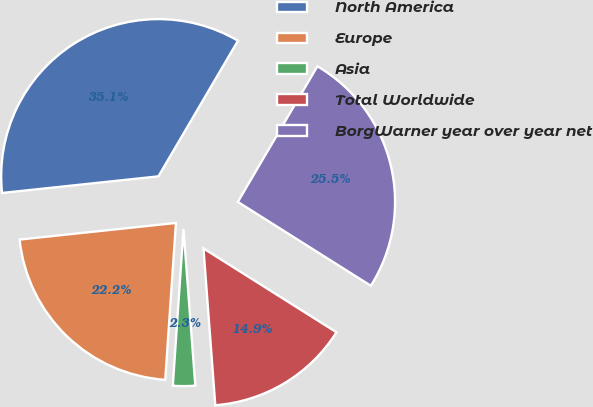Convert chart to OTSL. <chart><loc_0><loc_0><loc_500><loc_500><pie_chart><fcel>North America<fcel>Europe<fcel>Asia<fcel>Total Worldwide<fcel>BorgWarner year over year net<nl><fcel>35.13%<fcel>22.23%<fcel>2.28%<fcel>14.85%<fcel>25.51%<nl></chart> 